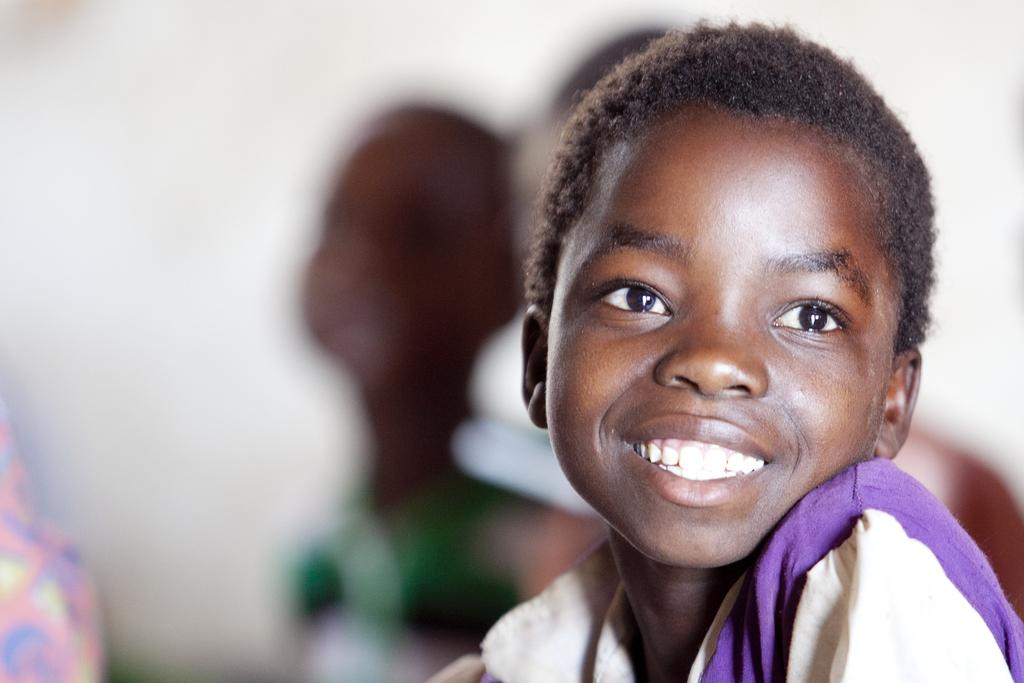Who is the main subject in the picture? There is a small boy in the picture. What is the small boy doing in the picture? The small boy is looking to the side and smiling. Are there any other children visible in the picture? Yes, there are two more boys visible in the background. How clear are the two boys in the background? The two boys in the background are not clearly visible. What type of heart-shaped object can be seen in the picture? There is no heart-shaped object present in the picture. What kind of boots is the small boy wearing in the picture? The small boy is not wearing any boots in the picture; he is barefoot. 